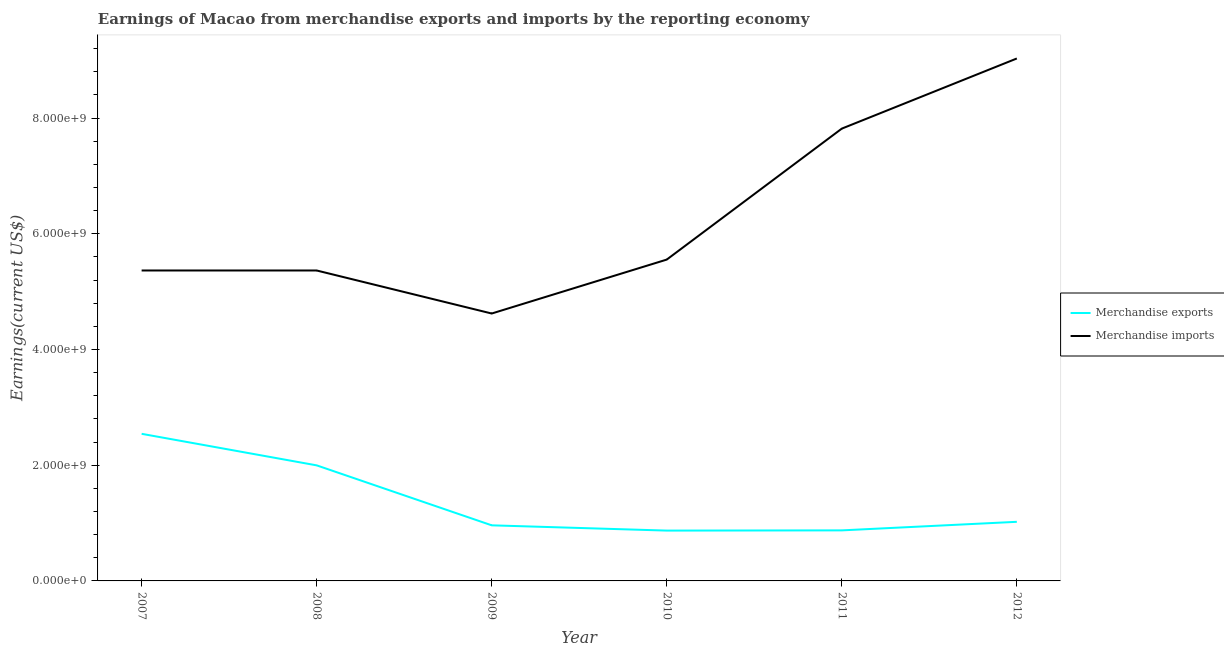How many different coloured lines are there?
Keep it short and to the point. 2. Does the line corresponding to earnings from merchandise imports intersect with the line corresponding to earnings from merchandise exports?
Your answer should be very brief. No. Is the number of lines equal to the number of legend labels?
Give a very brief answer. Yes. What is the earnings from merchandise exports in 2007?
Offer a terse response. 2.54e+09. Across all years, what is the maximum earnings from merchandise imports?
Your response must be concise. 9.03e+09. Across all years, what is the minimum earnings from merchandise imports?
Your response must be concise. 4.62e+09. In which year was the earnings from merchandise exports minimum?
Your answer should be very brief. 2010. What is the total earnings from merchandise exports in the graph?
Make the answer very short. 8.27e+09. What is the difference between the earnings from merchandise imports in 2011 and that in 2012?
Give a very brief answer. -1.21e+09. What is the difference between the earnings from merchandise imports in 2011 and the earnings from merchandise exports in 2008?
Provide a short and direct response. 5.82e+09. What is the average earnings from merchandise exports per year?
Your response must be concise. 1.38e+09. In the year 2010, what is the difference between the earnings from merchandise imports and earnings from merchandise exports?
Make the answer very short. 4.68e+09. What is the ratio of the earnings from merchandise exports in 2008 to that in 2012?
Your response must be concise. 1.96. What is the difference between the highest and the second highest earnings from merchandise exports?
Offer a terse response. 5.45e+08. What is the difference between the highest and the lowest earnings from merchandise exports?
Your answer should be very brief. 1.67e+09. Is the earnings from merchandise imports strictly less than the earnings from merchandise exports over the years?
Your answer should be very brief. No. How many lines are there?
Offer a terse response. 2. Does the graph contain any zero values?
Your answer should be very brief. No. Does the graph contain grids?
Provide a short and direct response. No. How many legend labels are there?
Offer a terse response. 2. What is the title of the graph?
Make the answer very short. Earnings of Macao from merchandise exports and imports by the reporting economy. What is the label or title of the Y-axis?
Keep it short and to the point. Earnings(current US$). What is the Earnings(current US$) of Merchandise exports in 2007?
Ensure brevity in your answer.  2.54e+09. What is the Earnings(current US$) of Merchandise imports in 2007?
Your response must be concise. 5.37e+09. What is the Earnings(current US$) of Merchandise exports in 2008?
Keep it short and to the point. 2.00e+09. What is the Earnings(current US$) in Merchandise imports in 2008?
Ensure brevity in your answer.  5.37e+09. What is the Earnings(current US$) of Merchandise exports in 2009?
Offer a terse response. 9.61e+08. What is the Earnings(current US$) of Merchandise imports in 2009?
Offer a very short reply. 4.62e+09. What is the Earnings(current US$) of Merchandise exports in 2010?
Provide a short and direct response. 8.70e+08. What is the Earnings(current US$) of Merchandise imports in 2010?
Give a very brief answer. 5.55e+09. What is the Earnings(current US$) of Merchandise exports in 2011?
Keep it short and to the point. 8.74e+08. What is the Earnings(current US$) in Merchandise imports in 2011?
Provide a short and direct response. 7.82e+09. What is the Earnings(current US$) of Merchandise exports in 2012?
Ensure brevity in your answer.  1.02e+09. What is the Earnings(current US$) in Merchandise imports in 2012?
Offer a very short reply. 9.03e+09. Across all years, what is the maximum Earnings(current US$) of Merchandise exports?
Offer a very short reply. 2.54e+09. Across all years, what is the maximum Earnings(current US$) of Merchandise imports?
Offer a terse response. 9.03e+09. Across all years, what is the minimum Earnings(current US$) in Merchandise exports?
Your answer should be compact. 8.70e+08. Across all years, what is the minimum Earnings(current US$) in Merchandise imports?
Ensure brevity in your answer.  4.62e+09. What is the total Earnings(current US$) in Merchandise exports in the graph?
Ensure brevity in your answer.  8.27e+09. What is the total Earnings(current US$) of Merchandise imports in the graph?
Keep it short and to the point. 3.78e+1. What is the difference between the Earnings(current US$) in Merchandise exports in 2007 and that in 2008?
Provide a short and direct response. 5.45e+08. What is the difference between the Earnings(current US$) of Merchandise imports in 2007 and that in 2008?
Offer a terse response. 9.03e+04. What is the difference between the Earnings(current US$) of Merchandise exports in 2007 and that in 2009?
Your answer should be compact. 1.58e+09. What is the difference between the Earnings(current US$) in Merchandise imports in 2007 and that in 2009?
Your response must be concise. 7.44e+08. What is the difference between the Earnings(current US$) in Merchandise exports in 2007 and that in 2010?
Give a very brief answer. 1.67e+09. What is the difference between the Earnings(current US$) of Merchandise imports in 2007 and that in 2010?
Your answer should be very brief. -1.88e+08. What is the difference between the Earnings(current US$) of Merchandise exports in 2007 and that in 2011?
Offer a terse response. 1.67e+09. What is the difference between the Earnings(current US$) of Merchandise imports in 2007 and that in 2011?
Offer a very short reply. -2.45e+09. What is the difference between the Earnings(current US$) in Merchandise exports in 2007 and that in 2012?
Provide a succinct answer. 1.52e+09. What is the difference between the Earnings(current US$) in Merchandise imports in 2007 and that in 2012?
Give a very brief answer. -3.66e+09. What is the difference between the Earnings(current US$) in Merchandise exports in 2008 and that in 2009?
Offer a terse response. 1.04e+09. What is the difference between the Earnings(current US$) in Merchandise imports in 2008 and that in 2009?
Ensure brevity in your answer.  7.44e+08. What is the difference between the Earnings(current US$) of Merchandise exports in 2008 and that in 2010?
Give a very brief answer. 1.13e+09. What is the difference between the Earnings(current US$) of Merchandise imports in 2008 and that in 2010?
Your answer should be very brief. -1.88e+08. What is the difference between the Earnings(current US$) in Merchandise exports in 2008 and that in 2011?
Ensure brevity in your answer.  1.12e+09. What is the difference between the Earnings(current US$) in Merchandise imports in 2008 and that in 2011?
Ensure brevity in your answer.  -2.45e+09. What is the difference between the Earnings(current US$) of Merchandise exports in 2008 and that in 2012?
Provide a short and direct response. 9.76e+08. What is the difference between the Earnings(current US$) in Merchandise imports in 2008 and that in 2012?
Give a very brief answer. -3.66e+09. What is the difference between the Earnings(current US$) in Merchandise exports in 2009 and that in 2010?
Give a very brief answer. 9.11e+07. What is the difference between the Earnings(current US$) of Merchandise imports in 2009 and that in 2010?
Your answer should be very brief. -9.32e+08. What is the difference between the Earnings(current US$) of Merchandise exports in 2009 and that in 2011?
Give a very brief answer. 8.74e+07. What is the difference between the Earnings(current US$) in Merchandise imports in 2009 and that in 2011?
Ensure brevity in your answer.  -3.20e+09. What is the difference between the Earnings(current US$) of Merchandise exports in 2009 and that in 2012?
Your answer should be very brief. -6.07e+07. What is the difference between the Earnings(current US$) in Merchandise imports in 2009 and that in 2012?
Ensure brevity in your answer.  -4.41e+09. What is the difference between the Earnings(current US$) of Merchandise exports in 2010 and that in 2011?
Ensure brevity in your answer.  -3.75e+06. What is the difference between the Earnings(current US$) in Merchandise imports in 2010 and that in 2011?
Give a very brief answer. -2.26e+09. What is the difference between the Earnings(current US$) in Merchandise exports in 2010 and that in 2012?
Your answer should be very brief. -1.52e+08. What is the difference between the Earnings(current US$) in Merchandise imports in 2010 and that in 2012?
Your answer should be very brief. -3.48e+09. What is the difference between the Earnings(current US$) in Merchandise exports in 2011 and that in 2012?
Make the answer very short. -1.48e+08. What is the difference between the Earnings(current US$) in Merchandise imports in 2011 and that in 2012?
Provide a succinct answer. -1.21e+09. What is the difference between the Earnings(current US$) of Merchandise exports in 2007 and the Earnings(current US$) of Merchandise imports in 2008?
Make the answer very short. -2.82e+09. What is the difference between the Earnings(current US$) in Merchandise exports in 2007 and the Earnings(current US$) in Merchandise imports in 2009?
Ensure brevity in your answer.  -2.08e+09. What is the difference between the Earnings(current US$) of Merchandise exports in 2007 and the Earnings(current US$) of Merchandise imports in 2010?
Your answer should be compact. -3.01e+09. What is the difference between the Earnings(current US$) of Merchandise exports in 2007 and the Earnings(current US$) of Merchandise imports in 2011?
Your answer should be compact. -5.27e+09. What is the difference between the Earnings(current US$) in Merchandise exports in 2007 and the Earnings(current US$) in Merchandise imports in 2012?
Ensure brevity in your answer.  -6.49e+09. What is the difference between the Earnings(current US$) in Merchandise exports in 2008 and the Earnings(current US$) in Merchandise imports in 2009?
Give a very brief answer. -2.62e+09. What is the difference between the Earnings(current US$) in Merchandise exports in 2008 and the Earnings(current US$) in Merchandise imports in 2010?
Your response must be concise. -3.56e+09. What is the difference between the Earnings(current US$) in Merchandise exports in 2008 and the Earnings(current US$) in Merchandise imports in 2011?
Your answer should be compact. -5.82e+09. What is the difference between the Earnings(current US$) of Merchandise exports in 2008 and the Earnings(current US$) of Merchandise imports in 2012?
Offer a very short reply. -7.03e+09. What is the difference between the Earnings(current US$) of Merchandise exports in 2009 and the Earnings(current US$) of Merchandise imports in 2010?
Offer a terse response. -4.59e+09. What is the difference between the Earnings(current US$) in Merchandise exports in 2009 and the Earnings(current US$) in Merchandise imports in 2011?
Make the answer very short. -6.86e+09. What is the difference between the Earnings(current US$) in Merchandise exports in 2009 and the Earnings(current US$) in Merchandise imports in 2012?
Keep it short and to the point. -8.07e+09. What is the difference between the Earnings(current US$) in Merchandise exports in 2010 and the Earnings(current US$) in Merchandise imports in 2011?
Ensure brevity in your answer.  -6.95e+09. What is the difference between the Earnings(current US$) of Merchandise exports in 2010 and the Earnings(current US$) of Merchandise imports in 2012?
Give a very brief answer. -8.16e+09. What is the difference between the Earnings(current US$) in Merchandise exports in 2011 and the Earnings(current US$) in Merchandise imports in 2012?
Offer a terse response. -8.16e+09. What is the average Earnings(current US$) in Merchandise exports per year?
Make the answer very short. 1.38e+09. What is the average Earnings(current US$) in Merchandise imports per year?
Make the answer very short. 6.29e+09. In the year 2007, what is the difference between the Earnings(current US$) of Merchandise exports and Earnings(current US$) of Merchandise imports?
Give a very brief answer. -2.82e+09. In the year 2008, what is the difference between the Earnings(current US$) of Merchandise exports and Earnings(current US$) of Merchandise imports?
Keep it short and to the point. -3.37e+09. In the year 2009, what is the difference between the Earnings(current US$) in Merchandise exports and Earnings(current US$) in Merchandise imports?
Offer a very short reply. -3.66e+09. In the year 2010, what is the difference between the Earnings(current US$) in Merchandise exports and Earnings(current US$) in Merchandise imports?
Provide a short and direct response. -4.68e+09. In the year 2011, what is the difference between the Earnings(current US$) in Merchandise exports and Earnings(current US$) in Merchandise imports?
Your answer should be compact. -6.94e+09. In the year 2012, what is the difference between the Earnings(current US$) of Merchandise exports and Earnings(current US$) of Merchandise imports?
Ensure brevity in your answer.  -8.01e+09. What is the ratio of the Earnings(current US$) in Merchandise exports in 2007 to that in 2008?
Give a very brief answer. 1.27. What is the ratio of the Earnings(current US$) in Merchandise exports in 2007 to that in 2009?
Your answer should be very brief. 2.65. What is the ratio of the Earnings(current US$) of Merchandise imports in 2007 to that in 2009?
Ensure brevity in your answer.  1.16. What is the ratio of the Earnings(current US$) of Merchandise exports in 2007 to that in 2010?
Offer a very short reply. 2.92. What is the ratio of the Earnings(current US$) in Merchandise imports in 2007 to that in 2010?
Your answer should be very brief. 0.97. What is the ratio of the Earnings(current US$) in Merchandise exports in 2007 to that in 2011?
Provide a succinct answer. 2.91. What is the ratio of the Earnings(current US$) of Merchandise imports in 2007 to that in 2011?
Give a very brief answer. 0.69. What is the ratio of the Earnings(current US$) of Merchandise exports in 2007 to that in 2012?
Offer a very short reply. 2.49. What is the ratio of the Earnings(current US$) in Merchandise imports in 2007 to that in 2012?
Offer a terse response. 0.59. What is the ratio of the Earnings(current US$) of Merchandise exports in 2008 to that in 2009?
Your answer should be very brief. 2.08. What is the ratio of the Earnings(current US$) of Merchandise imports in 2008 to that in 2009?
Offer a very short reply. 1.16. What is the ratio of the Earnings(current US$) of Merchandise exports in 2008 to that in 2010?
Your answer should be compact. 2.3. What is the ratio of the Earnings(current US$) in Merchandise imports in 2008 to that in 2010?
Give a very brief answer. 0.97. What is the ratio of the Earnings(current US$) of Merchandise exports in 2008 to that in 2011?
Give a very brief answer. 2.29. What is the ratio of the Earnings(current US$) of Merchandise imports in 2008 to that in 2011?
Ensure brevity in your answer.  0.69. What is the ratio of the Earnings(current US$) in Merchandise exports in 2008 to that in 2012?
Your answer should be very brief. 1.96. What is the ratio of the Earnings(current US$) of Merchandise imports in 2008 to that in 2012?
Give a very brief answer. 0.59. What is the ratio of the Earnings(current US$) of Merchandise exports in 2009 to that in 2010?
Give a very brief answer. 1.1. What is the ratio of the Earnings(current US$) in Merchandise imports in 2009 to that in 2010?
Keep it short and to the point. 0.83. What is the ratio of the Earnings(current US$) in Merchandise imports in 2009 to that in 2011?
Provide a succinct answer. 0.59. What is the ratio of the Earnings(current US$) in Merchandise exports in 2009 to that in 2012?
Your response must be concise. 0.94. What is the ratio of the Earnings(current US$) of Merchandise imports in 2009 to that in 2012?
Provide a succinct answer. 0.51. What is the ratio of the Earnings(current US$) in Merchandise exports in 2010 to that in 2011?
Your answer should be compact. 1. What is the ratio of the Earnings(current US$) in Merchandise imports in 2010 to that in 2011?
Your response must be concise. 0.71. What is the ratio of the Earnings(current US$) in Merchandise exports in 2010 to that in 2012?
Give a very brief answer. 0.85. What is the ratio of the Earnings(current US$) of Merchandise imports in 2010 to that in 2012?
Provide a succinct answer. 0.62. What is the ratio of the Earnings(current US$) of Merchandise exports in 2011 to that in 2012?
Make the answer very short. 0.86. What is the ratio of the Earnings(current US$) in Merchandise imports in 2011 to that in 2012?
Offer a very short reply. 0.87. What is the difference between the highest and the second highest Earnings(current US$) of Merchandise exports?
Your answer should be compact. 5.45e+08. What is the difference between the highest and the second highest Earnings(current US$) in Merchandise imports?
Give a very brief answer. 1.21e+09. What is the difference between the highest and the lowest Earnings(current US$) of Merchandise exports?
Your answer should be very brief. 1.67e+09. What is the difference between the highest and the lowest Earnings(current US$) in Merchandise imports?
Keep it short and to the point. 4.41e+09. 